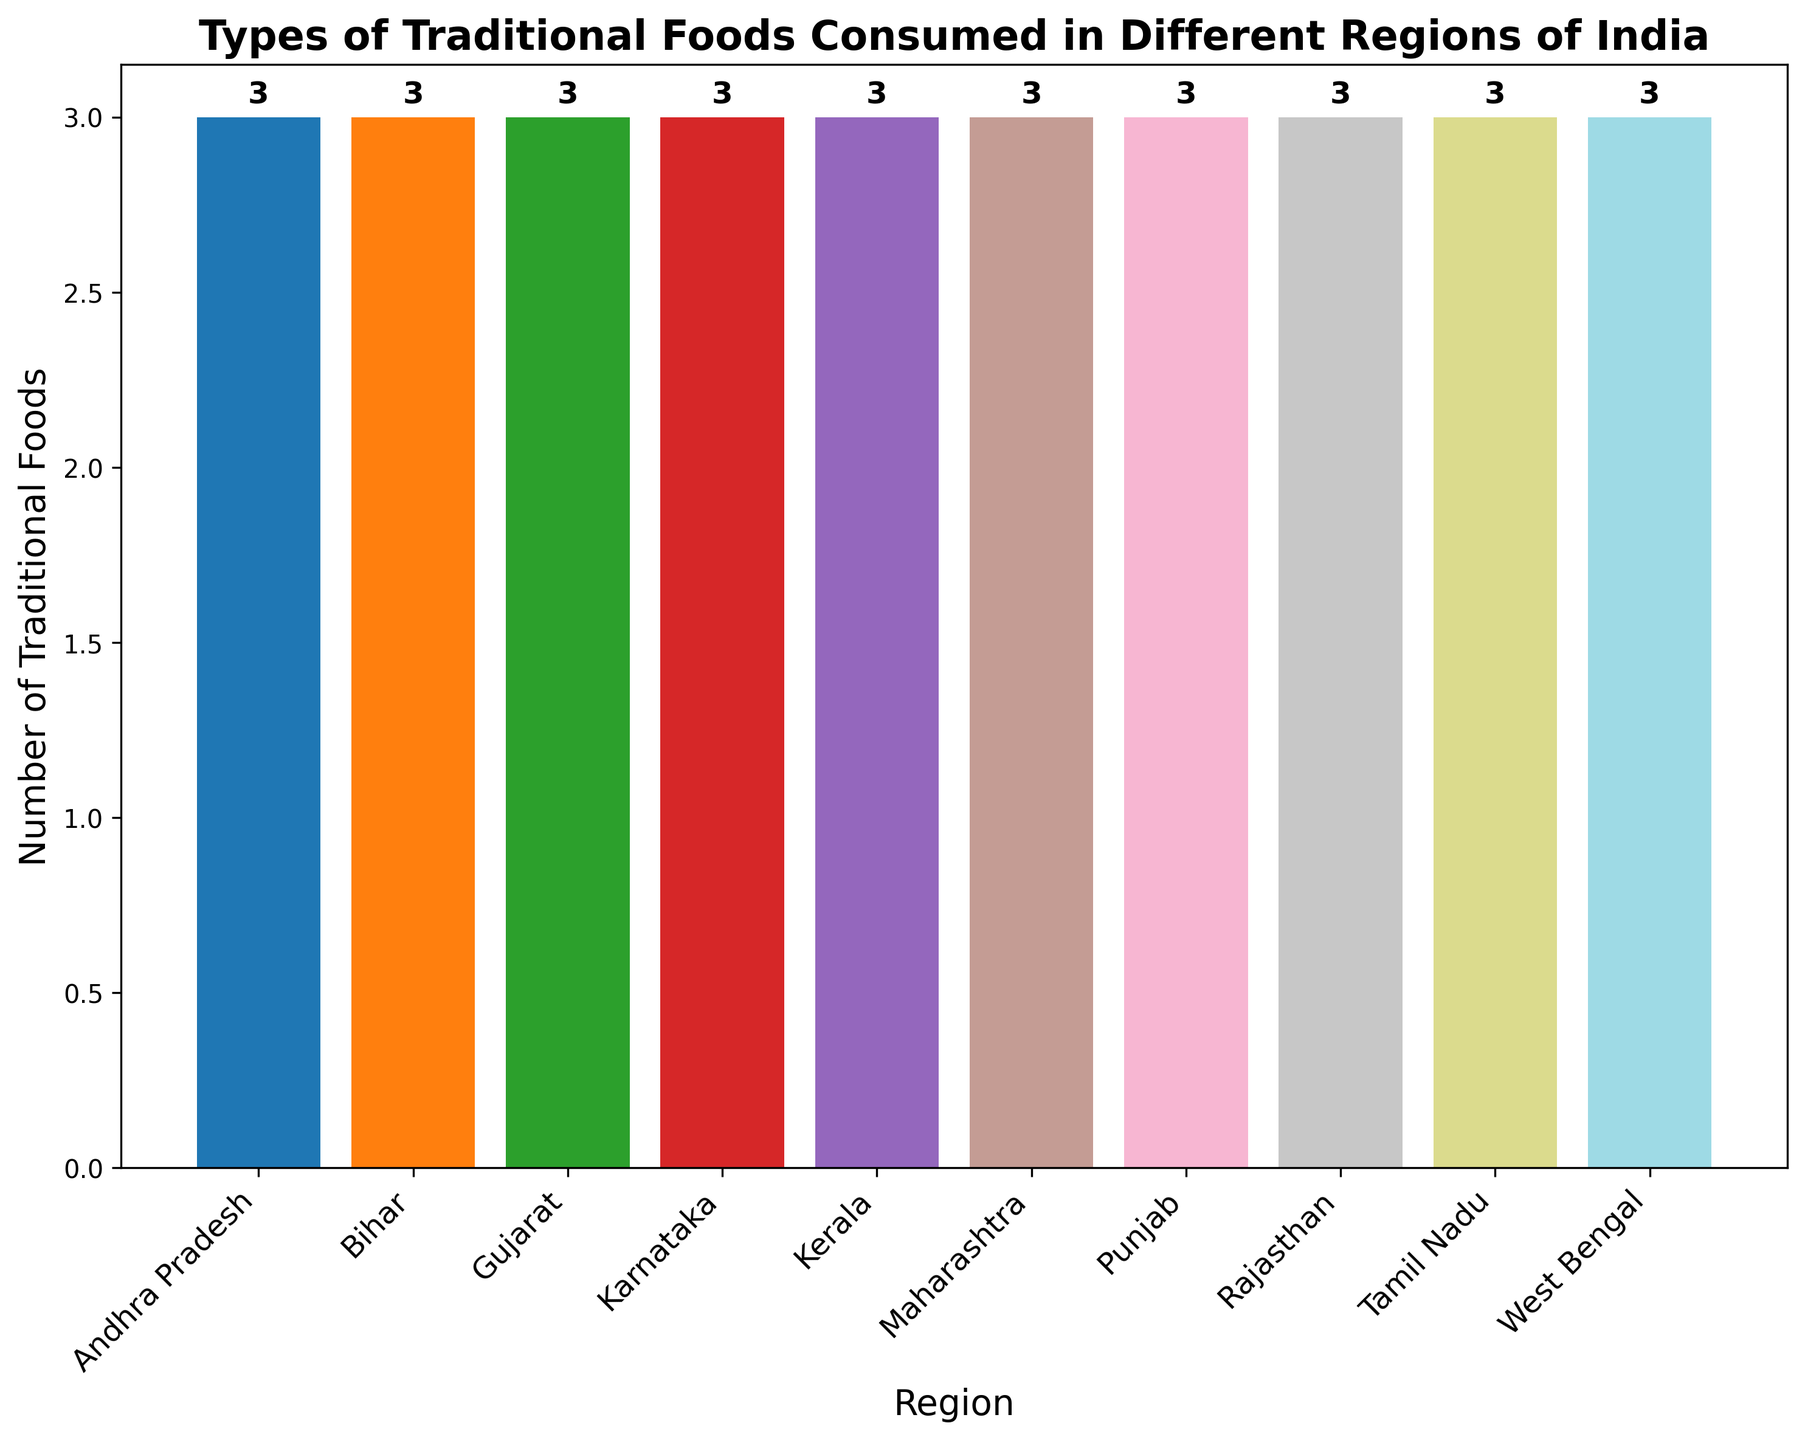Which region has the highest number of traditional foods listed? To determine the region with the highest number of traditional foods, check the heights of the bars. Punjab has the tallest bar.
Answer: Punjab Which two regions have an equal number of traditional foods? Compare the heights of all the bars. Rajasthan and Bihar both have bars of equal height, indicating the same number of traditional foods.
Answer: Rajasthan and Bihar What is the difference in the number of traditional foods between Tamil Nadu and Gujarat? Find the height of the bars representing Tamil Nadu and Gujarat, then subtract the smaller value from the larger value. Both regions have 3 traditional foods, so the difference is 0.
Answer: 0 What is the average number of traditional foods listed per region? Sum the heights of all the bars (i.e., 3+3+3+3+3+3+3+3+3) to get 27, then divide by the number of regions, which is 9. The average is 27/9.
Answer: 3 Which region has fewer traditional foods, Kerala or Karnataka? Compare the heights of the bars for Kerala and Karnataka. Both regions have bars of the same height, indicating equal numbers.
Answer: Equal What is the total number of traditional foods listed across all regions? Add up the heights of all the bars representing the regions (3 for each of the 9 regions). The total is 9 regions * 3 traditional foods each.
Answer: 27 In terms of visual appearance, which region's bar is colored the fourth in the sequence? Based on the color sequence of the bars, the fourth region (Maharashtra) bar is colored accordingly.
Answer: Maharashtra If you combine the counts of traditional foods from West Bengal and Andhra Pradesh, what is the total? Add the counts from West Bengal (3) and Andhra Pradesh (3). The total is 3 + 3.
Answer: 6 Which region's bar appears first when reading from left to right in the plot? Identify the first bar on the left side of the plot. Punjab is the first bar.
Answer: Punjab How many regions have exactly three types of traditional foods listed? Count the number of bars with a height representing three types of traditional foods. All regions have three types each.
Answer: 9 